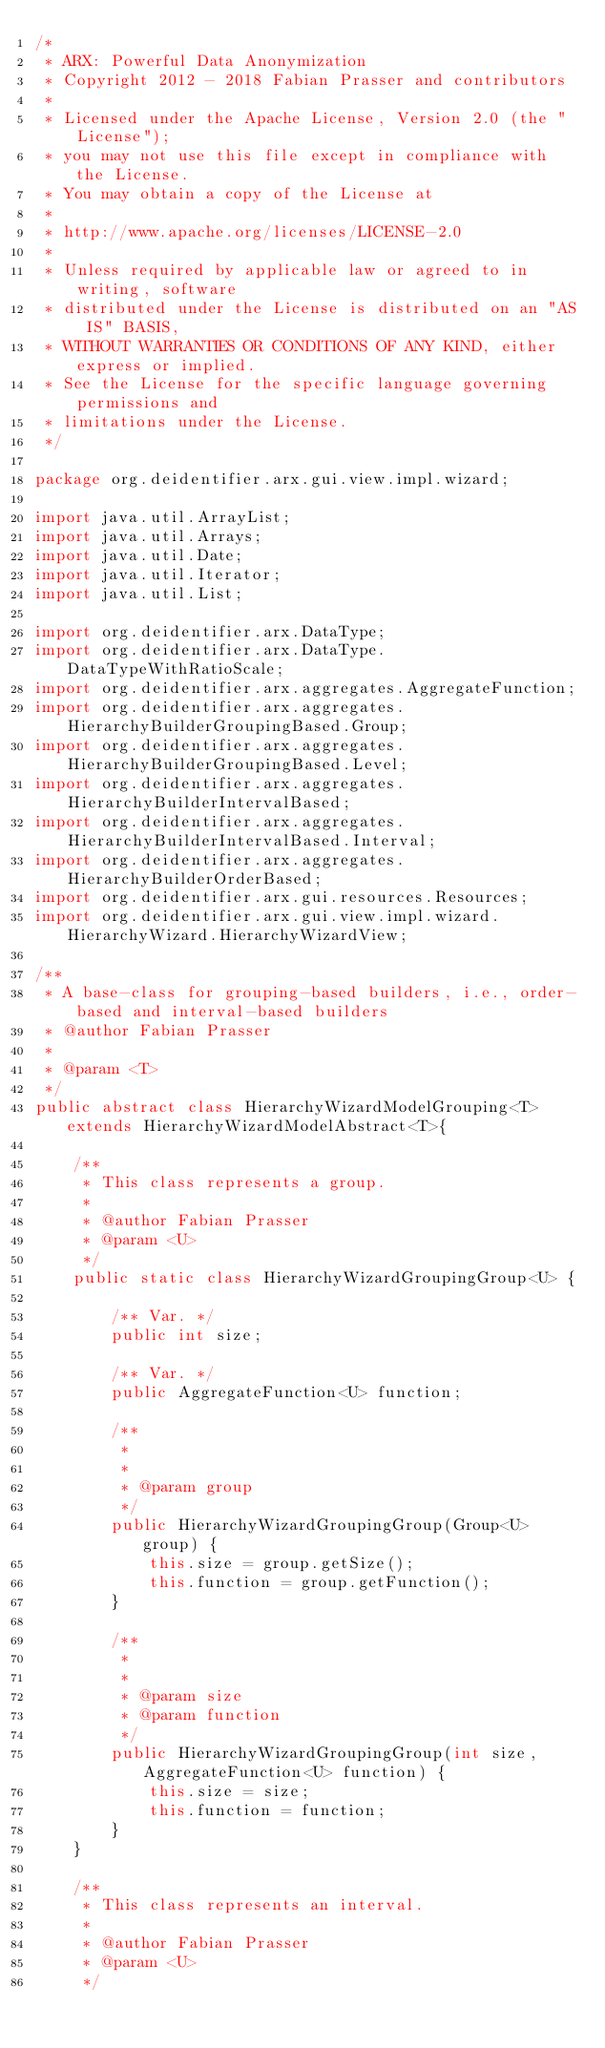<code> <loc_0><loc_0><loc_500><loc_500><_Java_>/*
 * ARX: Powerful Data Anonymization
 * Copyright 2012 - 2018 Fabian Prasser and contributors
 * 
 * Licensed under the Apache License, Version 2.0 (the "License");
 * you may not use this file except in compliance with the License.
 * You may obtain a copy of the License at
 * 
 * http://www.apache.org/licenses/LICENSE-2.0
 * 
 * Unless required by applicable law or agreed to in writing, software
 * distributed under the License is distributed on an "AS IS" BASIS,
 * WITHOUT WARRANTIES OR CONDITIONS OF ANY KIND, either express or implied.
 * See the License for the specific language governing permissions and
 * limitations under the License.
 */

package org.deidentifier.arx.gui.view.impl.wizard;

import java.util.ArrayList;
import java.util.Arrays;
import java.util.Date;
import java.util.Iterator;
import java.util.List;

import org.deidentifier.arx.DataType;
import org.deidentifier.arx.DataType.DataTypeWithRatioScale;
import org.deidentifier.arx.aggregates.AggregateFunction;
import org.deidentifier.arx.aggregates.HierarchyBuilderGroupingBased.Group;
import org.deidentifier.arx.aggregates.HierarchyBuilderGroupingBased.Level;
import org.deidentifier.arx.aggregates.HierarchyBuilderIntervalBased;
import org.deidentifier.arx.aggregates.HierarchyBuilderIntervalBased.Interval;
import org.deidentifier.arx.aggregates.HierarchyBuilderOrderBased;
import org.deidentifier.arx.gui.resources.Resources;
import org.deidentifier.arx.gui.view.impl.wizard.HierarchyWizard.HierarchyWizardView;

/**
 * A base-class for grouping-based builders, i.e., order-based and interval-based builders
 * @author Fabian Prasser
 *
 * @param <T>
 */
public abstract class HierarchyWizardModelGrouping<T> extends HierarchyWizardModelAbstract<T>{
    
    /**
     * This class represents a group.
     *
     * @author Fabian Prasser
     * @param <U>
     */
    public static class HierarchyWizardGroupingGroup<U> {
        
        /** Var. */
        public int size;
        
        /** Var. */
        public AggregateFunction<U> function;
        
        /**
         * 
         *
         * @param group
         */
        public HierarchyWizardGroupingGroup(Group<U> group) {
            this.size = group.getSize();
            this.function = group.getFunction();
        }

        /**
         * 
         *
         * @param size
         * @param function
         */
        public HierarchyWizardGroupingGroup(int size, AggregateFunction<U> function) {
            this.size = size;
            this.function = function;
        }
    }

    /**
     * This class represents an interval.
     *
     * @author Fabian Prasser
     * @param <U>
     */</code> 